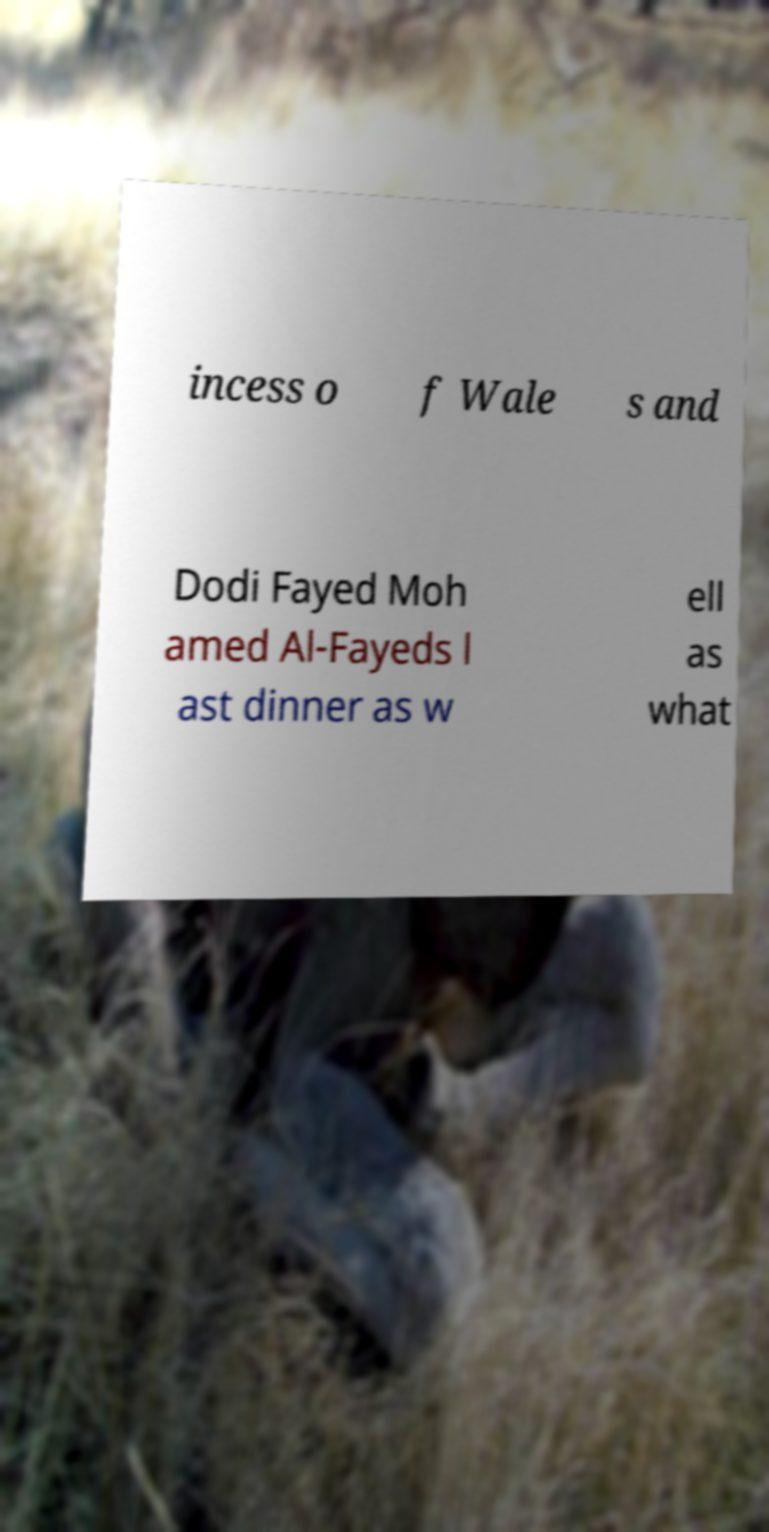There's text embedded in this image that I need extracted. Can you transcribe it verbatim? incess o f Wale s and Dodi Fayed Moh amed Al-Fayeds l ast dinner as w ell as what 